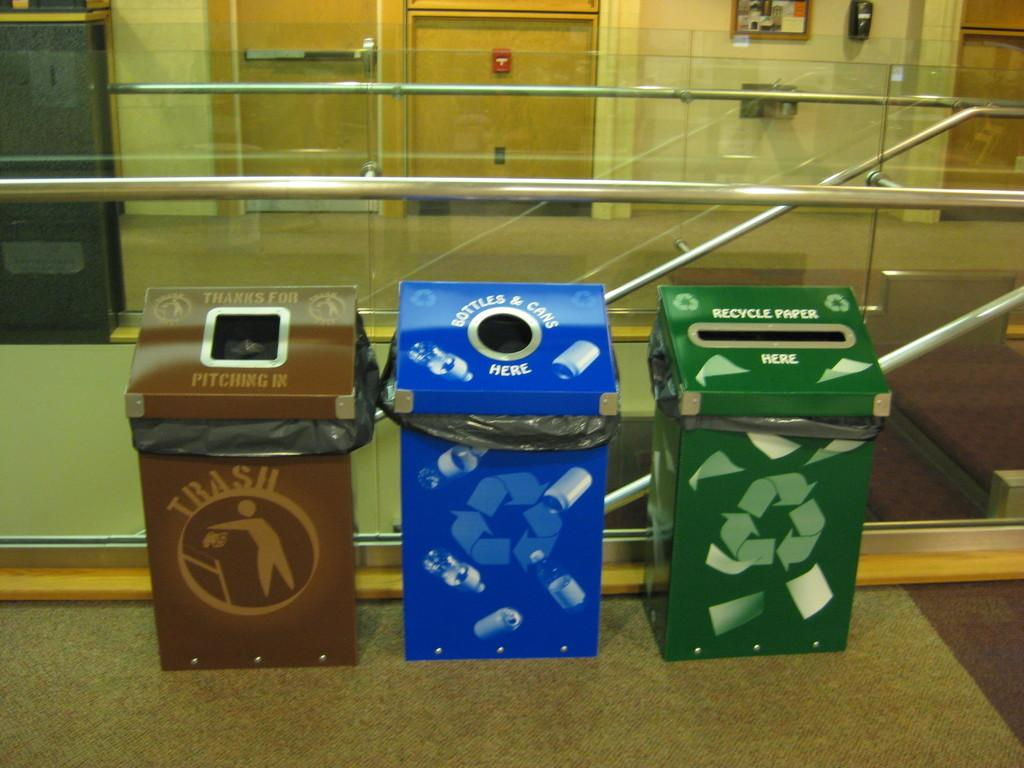<image>
Create a compact narrative representing the image presented. A couple of recycling bins for paper, bottles, and cans sit next to a stair case. 